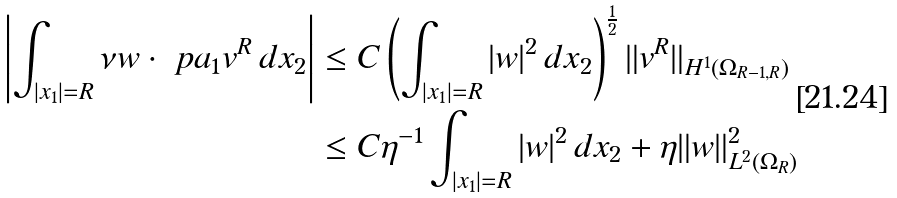<formula> <loc_0><loc_0><loc_500><loc_500>\left | \int _ { | x _ { 1 } | = R } \nu w \cdot \ p a _ { 1 } v ^ { R } \, d x _ { 2 } \right | & \leq C \left ( \int _ { | x _ { 1 } | = R } | w | ^ { 2 } \, d x _ { 2 } \right ) ^ { \frac { 1 } { 2 } } \| v ^ { R } \| _ { H ^ { 1 } ( \Omega _ { R - 1 , R } ) } \\ & \leq C \eta ^ { - 1 } \int _ { | x _ { 1 } | = R } | w | ^ { 2 } \, d x _ { 2 } + \eta \| w \| _ { L ^ { 2 } ( \Omega _ { R } ) } ^ { 2 }</formula> 